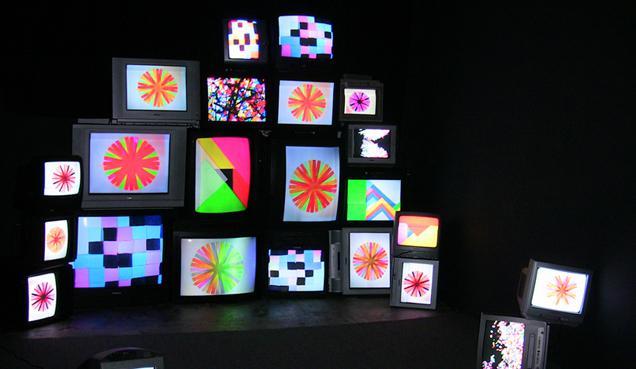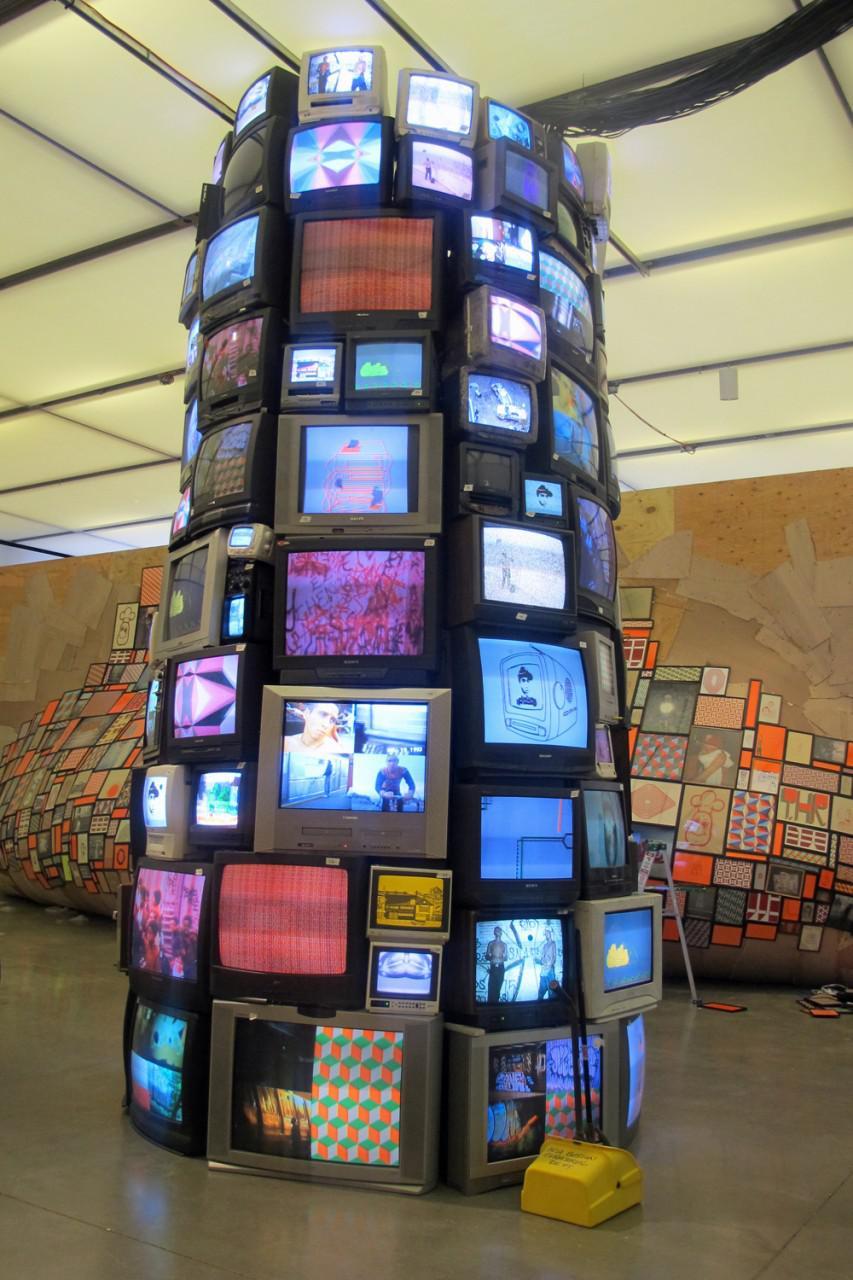The first image is the image on the left, the second image is the image on the right. For the images shown, is this caption "One of the images has less than ten TVs." true? Answer yes or no. No. The first image is the image on the left, the second image is the image on the right. Analyze the images presented: Is the assertion "In one image there are television sets being displayed as art arranged in a column." valid? Answer yes or no. Yes. 